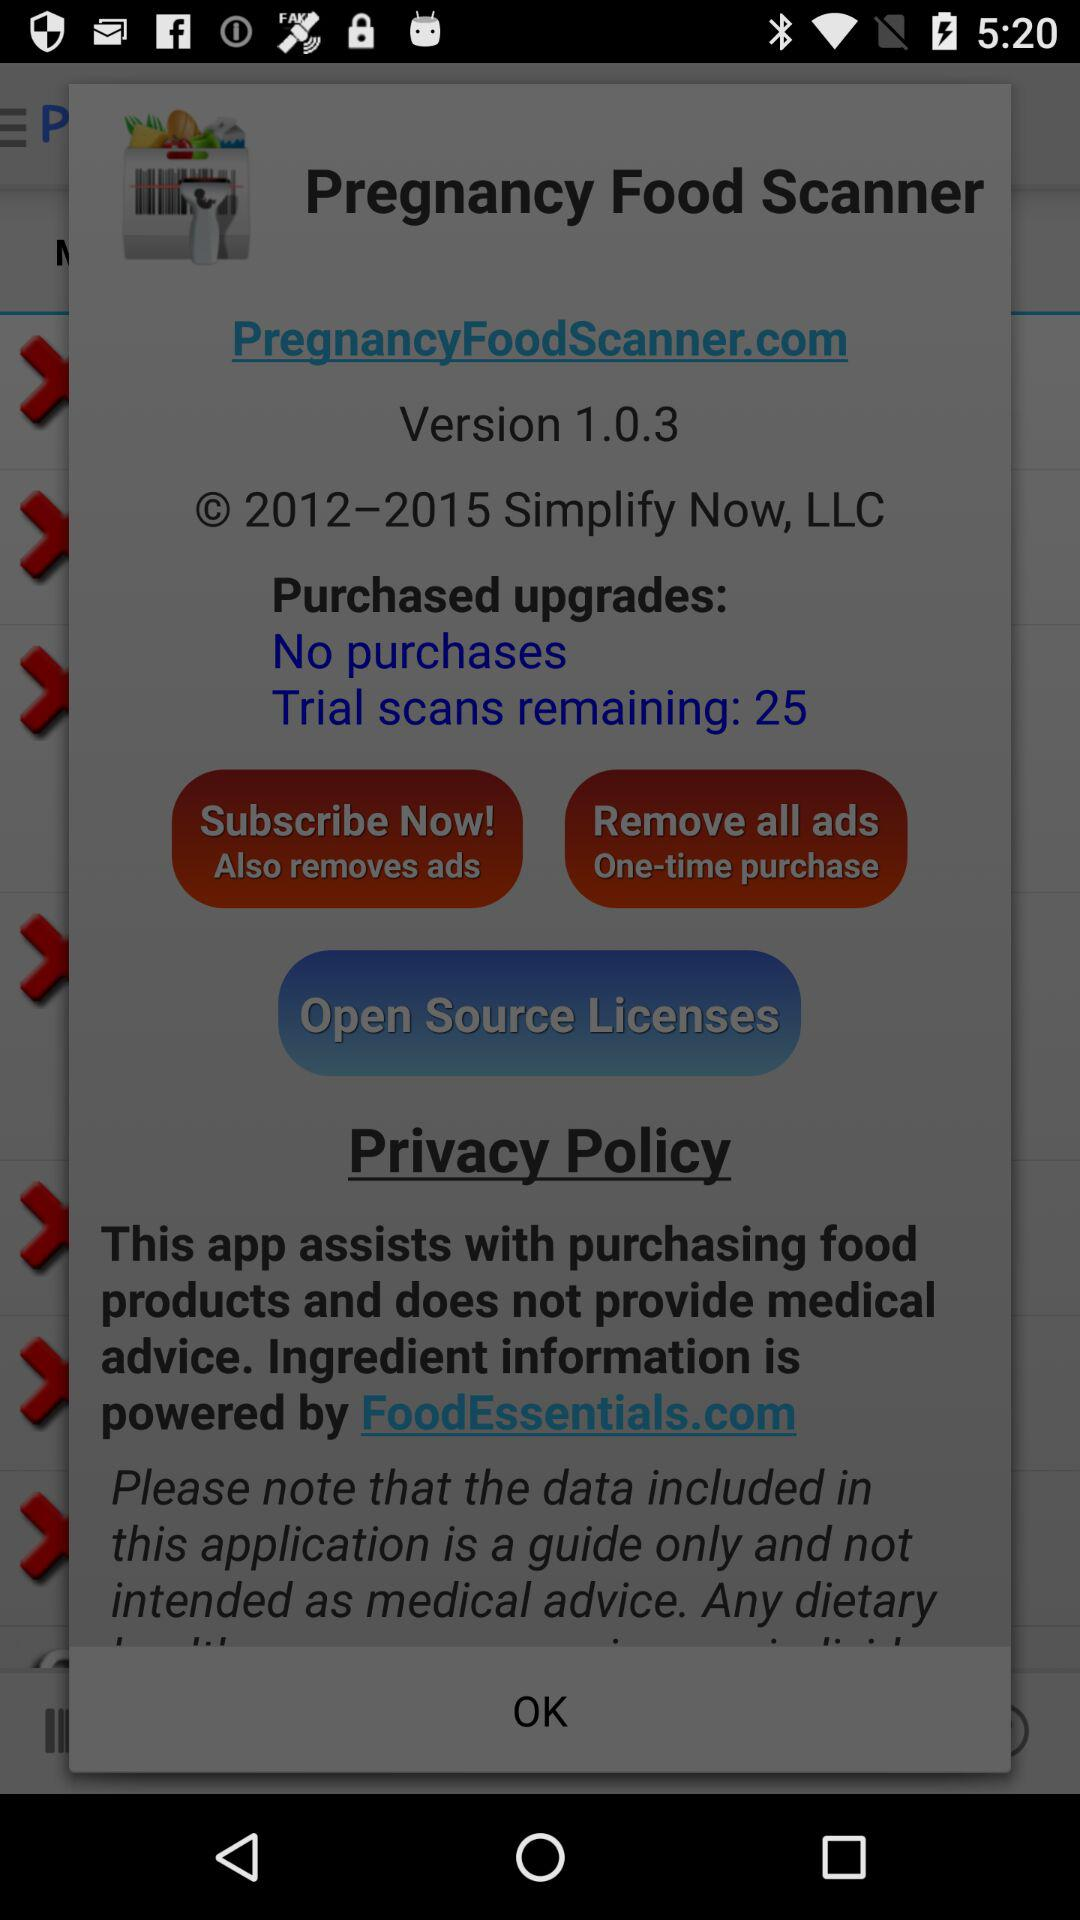Who is the user?
When the provided information is insufficient, respond with <no answer>. <no answer> 